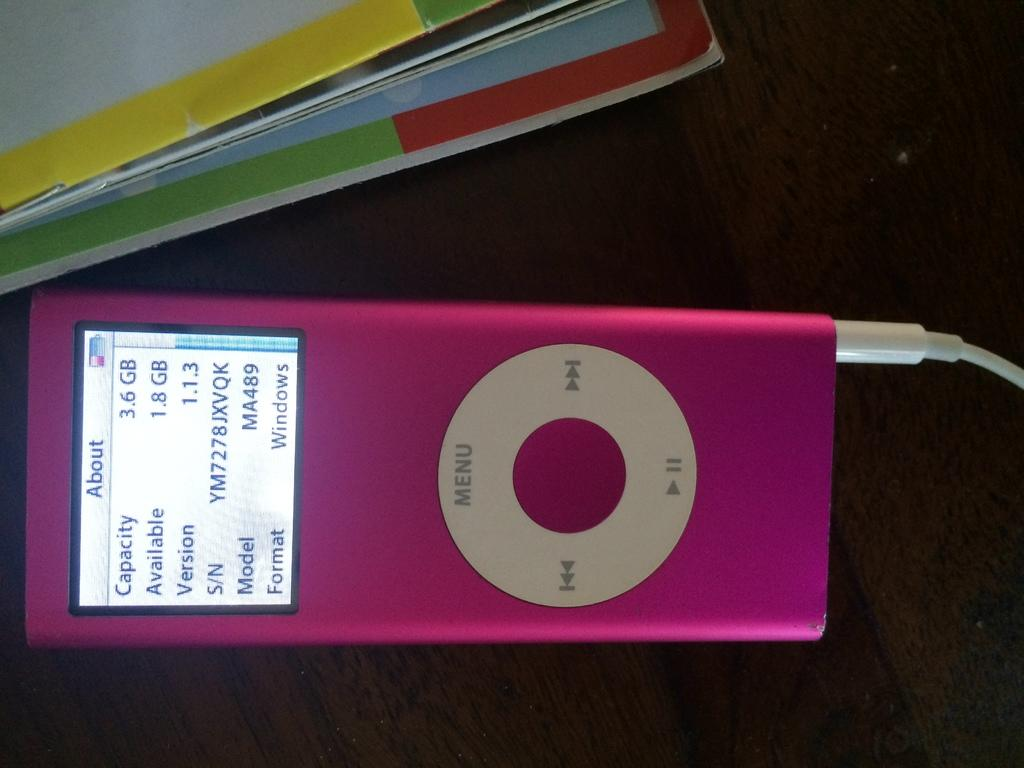What electronic device is visible in the image? There is an iPod in the image. What type of items are also present in the image? There are books in the image. On what surface are the iPod and books placed? The iPod and books are on a wooden table. How many books are teetering on the edge of the table in the image? There is no indication in the image that any books are teetering on the edge of the table. Did the earthquake cause the iPod and books to fall off the table in the image? There is no mention of an earthquake in the image, and the iPod and books appear to be stable on the table. 